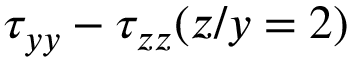Convert formula to latex. <formula><loc_0><loc_0><loc_500><loc_500>\tau _ { y y } - \tau _ { z z } ( z / y = 2 )</formula> 